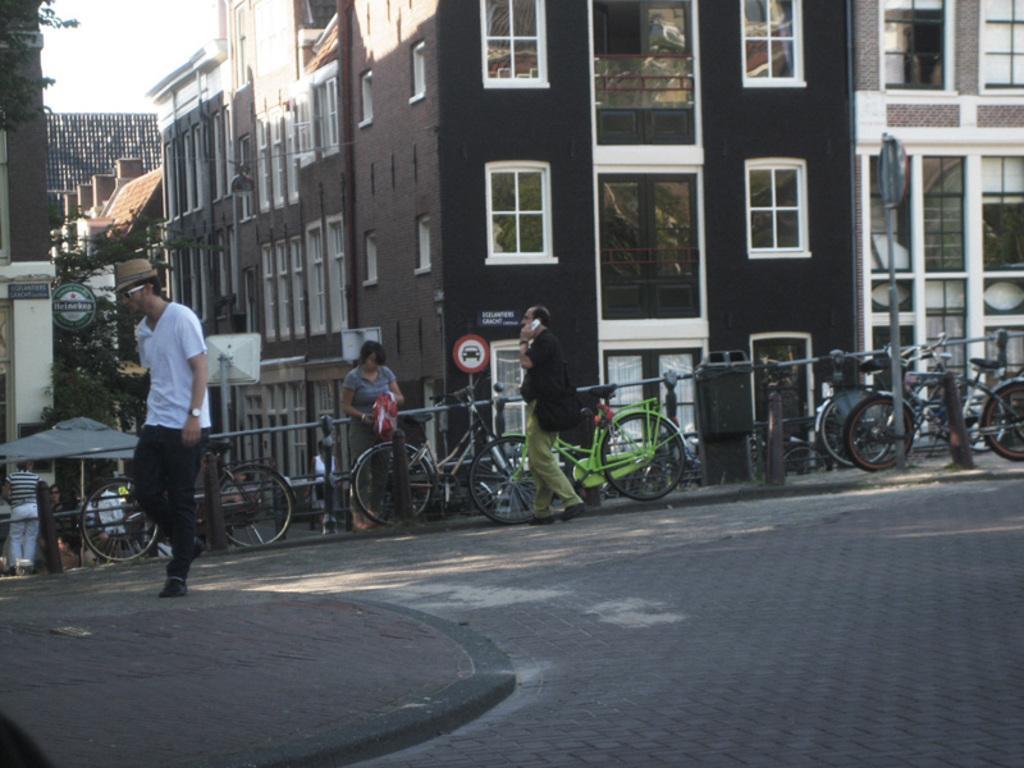Describe this image in one or two sentences. In this picture we can describe about the brown color building with white windows. Behind there are many cycles are parked. In front side we can see a boy wearing white color t-shirt and black track is walking on the cobbler stones. 